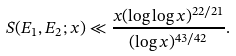<formula> <loc_0><loc_0><loc_500><loc_500>S ( E _ { 1 } , E _ { 2 } ; x ) \ll \frac { x ( \log \log x ) ^ { 2 2 / 2 1 } } { ( \log x ) ^ { 4 3 / 4 2 } } .</formula> 